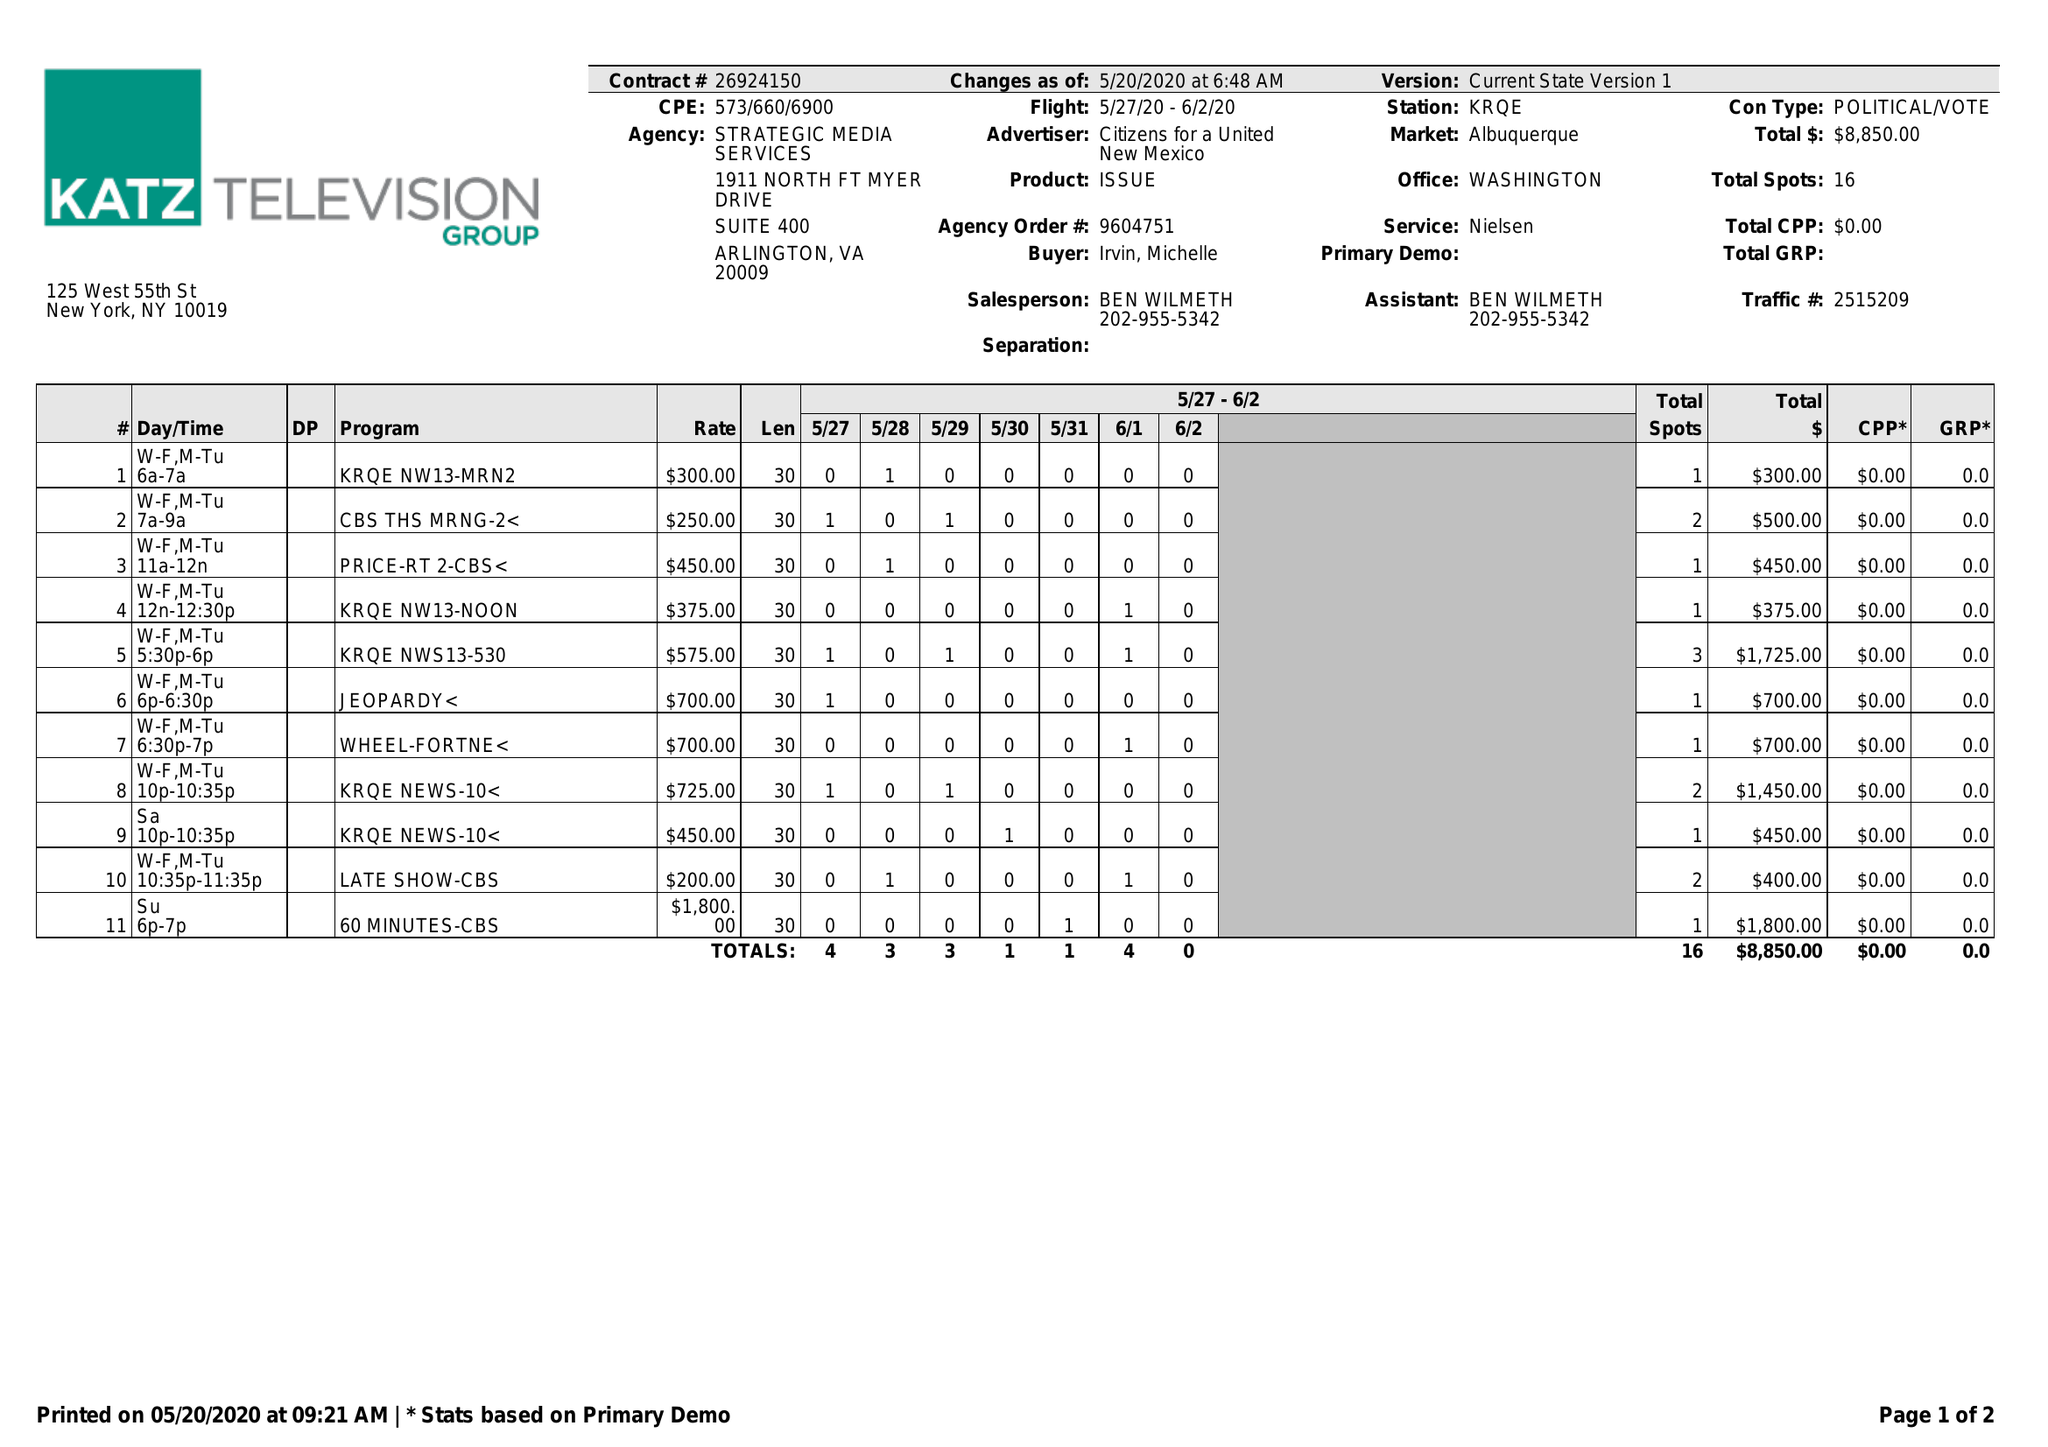What is the value for the flight_to?
Answer the question using a single word or phrase. 06/02/20 